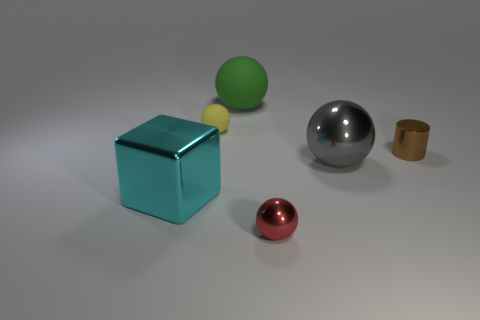What is the color of the rubber object behind the yellow sphere?
Provide a succinct answer. Green. There is a small sphere behind the small cylinder that is behind the large block; what is its material?
Provide a succinct answer. Rubber. What shape is the tiny yellow rubber thing?
Offer a terse response. Sphere. There is a large gray object that is the same shape as the tiny red shiny object; what material is it?
Offer a terse response. Metal. What number of rubber balls are the same size as the red object?
Ensure brevity in your answer.  1. Are there any small brown metal cylinders to the left of the tiny object right of the tiny red object?
Make the answer very short. No. How many brown things are metal cubes or tiny metallic blocks?
Your answer should be very brief. 0. What is the color of the small matte ball?
Keep it short and to the point. Yellow. The cyan object that is the same material as the large gray object is what size?
Your answer should be very brief. Large. What number of other small brown metallic objects are the same shape as the brown metallic object?
Give a very brief answer. 0. 